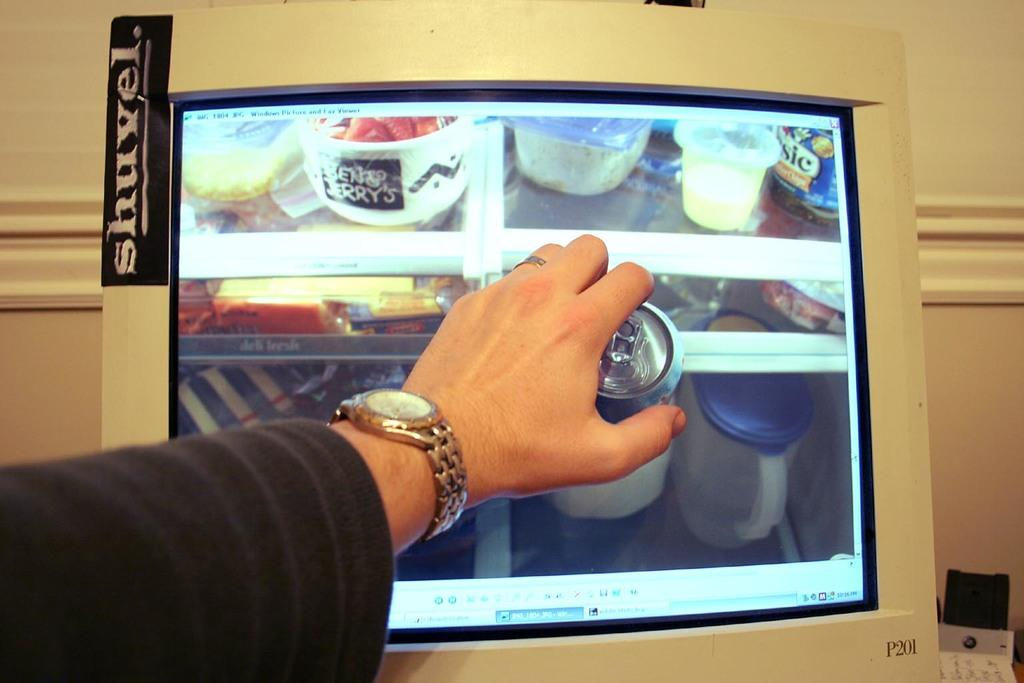<image>
Write a terse but informative summary of the picture. A Shuvel branded pc is on display while a man reaches for a drink. 